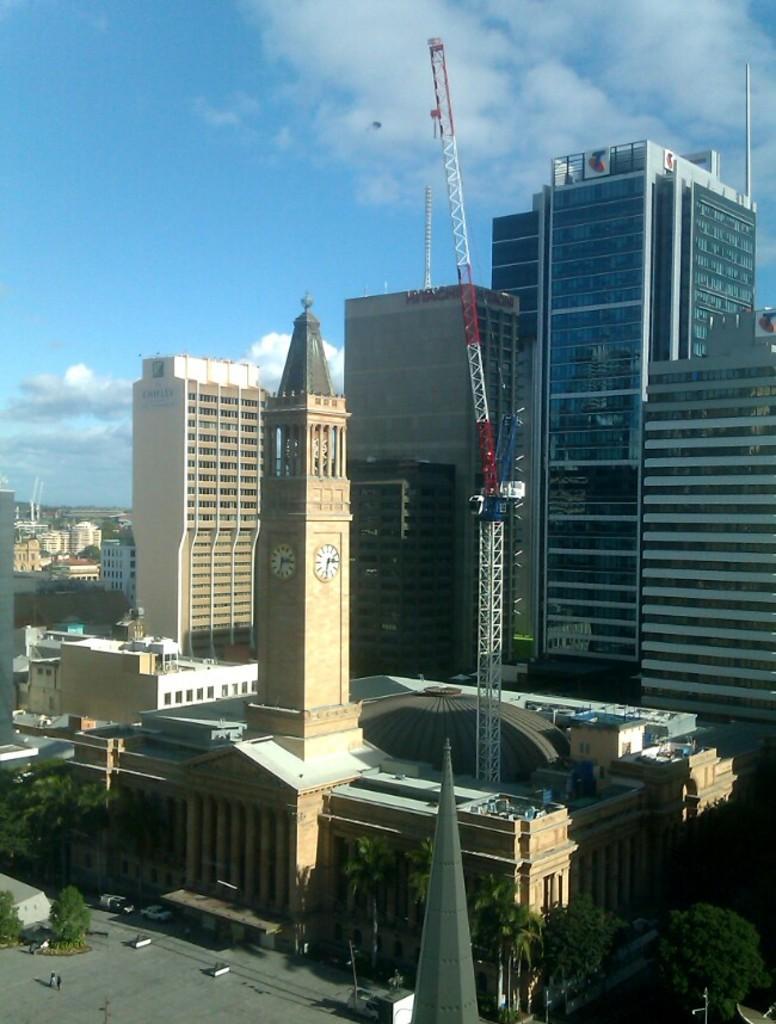How would you summarize this image in a sentence or two? In the image in the center we can see buildings,poles,trees,vehicles and clock tower. In the background we can see the sky and clouds. 